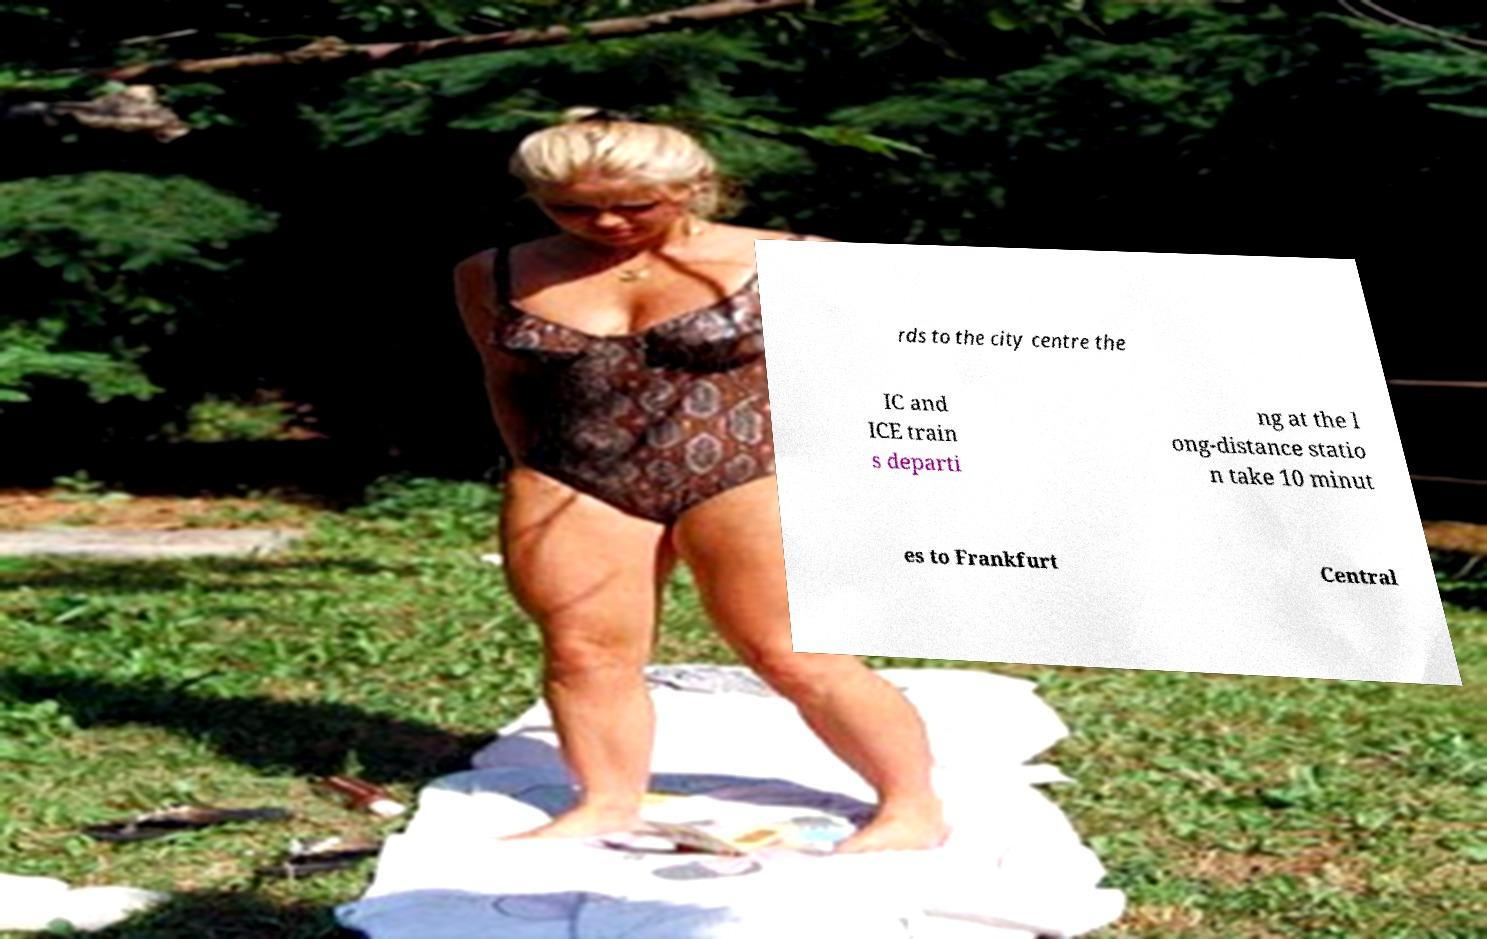I need the written content from this picture converted into text. Can you do that? rds to the city centre the IC and ICE train s departi ng at the l ong-distance statio n take 10 minut es to Frankfurt Central 